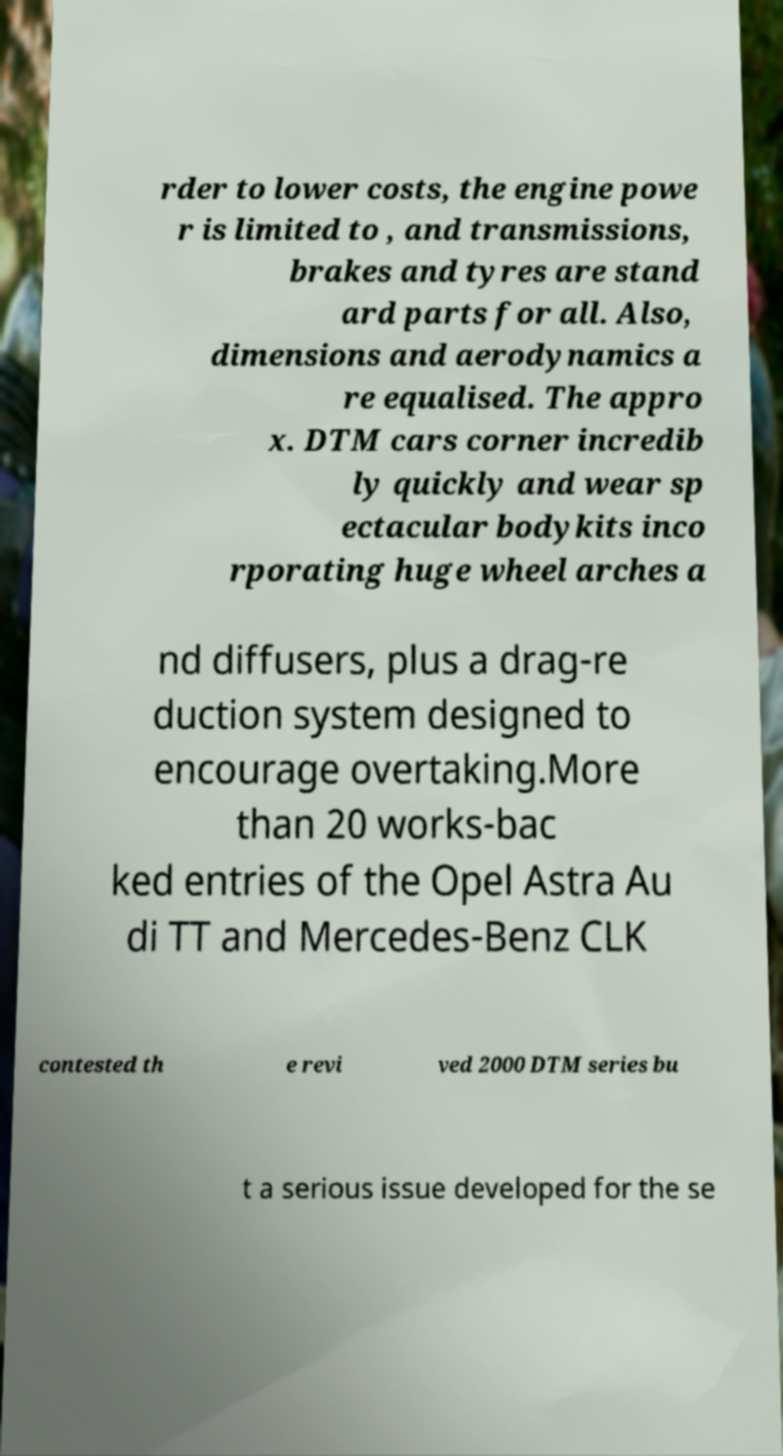Please read and relay the text visible in this image. What does it say? rder to lower costs, the engine powe r is limited to , and transmissions, brakes and tyres are stand ard parts for all. Also, dimensions and aerodynamics a re equalised. The appro x. DTM cars corner incredib ly quickly and wear sp ectacular bodykits inco rporating huge wheel arches a nd diffusers, plus a drag-re duction system designed to encourage overtaking.More than 20 works-bac ked entries of the Opel Astra Au di TT and Mercedes-Benz CLK contested th e revi ved 2000 DTM series bu t a serious issue developed for the se 